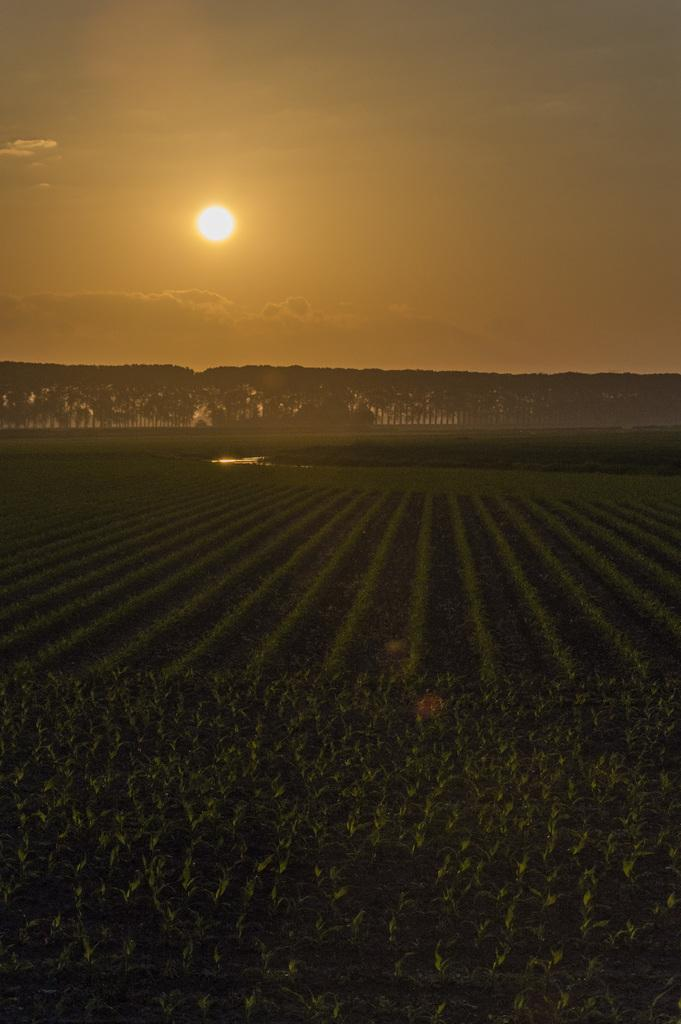What can be seen at the top of the image? The sky is visible towards the top of the image. What is present in the sky? The sun is present in the sky. What type of vegetation can be seen in the image? There are trees in the image. What else is visible in the image besides the sky and trees? There is water visible in the image. What is located towards the bottom of the image? Plants are present towards the bottom of the image. What type of pipe is being used by the dolls in the image? There are no dolls or pipes present in the image. How do the dolls move around in the image? There are no dolls present in the image, so they cannot move around. 